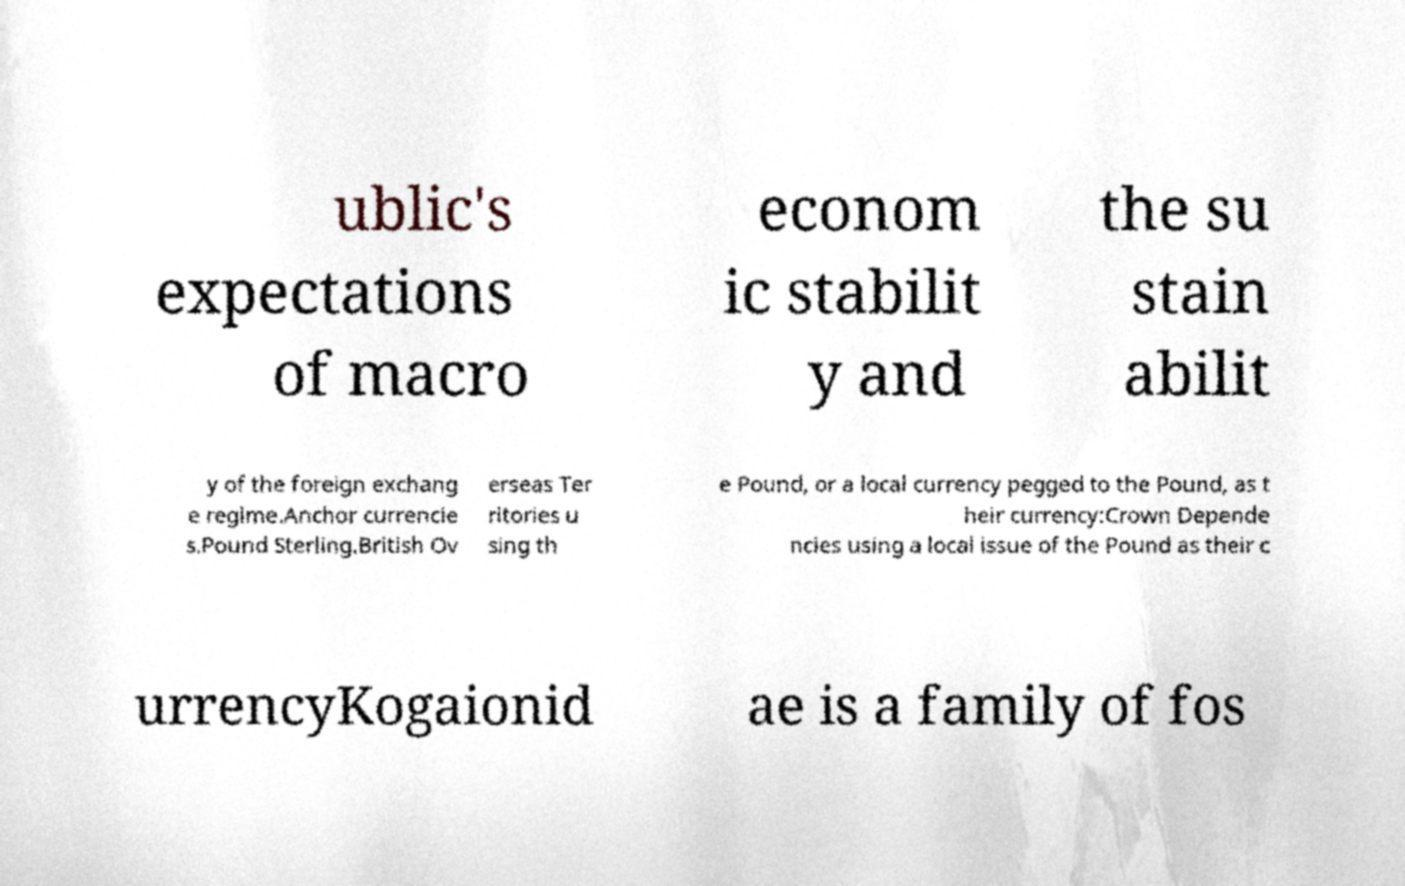What messages or text are displayed in this image? I need them in a readable, typed format. ublic's expectations of macro econom ic stabilit y and the su stain abilit y of the foreign exchang e regime.Anchor currencie s.Pound Sterling.British Ov erseas Ter ritories u sing th e Pound, or a local currency pegged to the Pound, as t heir currency:Crown Depende ncies using a local issue of the Pound as their c urrencyKogaionid ae is a family of fos 